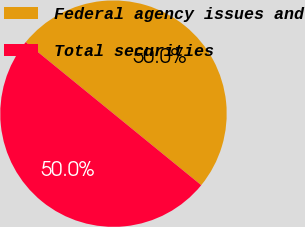<chart> <loc_0><loc_0><loc_500><loc_500><pie_chart><fcel>Federal agency issues and<fcel>Total securities<nl><fcel>50.0%<fcel>50.0%<nl></chart> 